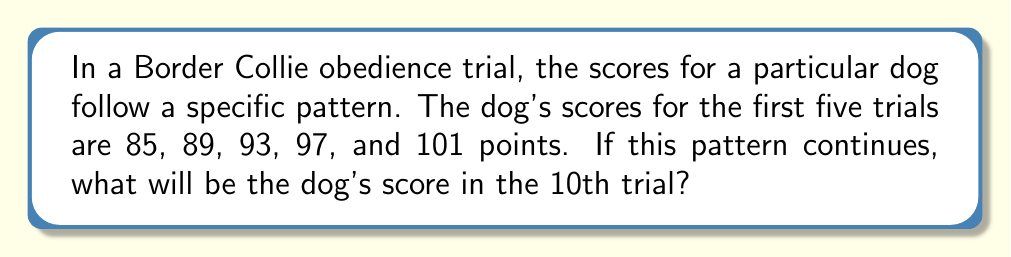Show me your answer to this math problem. To solve this problem, we need to follow these steps:

1. Identify the pattern in the given sequence:
   85, 89, 93, 97, 101

2. Calculate the difference between consecutive terms:
   89 - 85 = 4
   93 - 89 = 4
   97 - 93 = 4
   101 - 97 = 4

3. Recognize that this is an arithmetic sequence with a common difference of 4.

4. Use the arithmetic sequence formula:
   $$a_n = a_1 + (n - 1)d$$
   Where:
   $a_n$ is the nth term
   $a_1$ is the first term
   $n$ is the position of the term we're looking for
   $d$ is the common difference

5. Substitute the values:
   $a_1 = 85$ (first term)
   $n = 10$ (we want the 10th trial)
   $d = 4$ (common difference)

6. Calculate:
   $$a_{10} = 85 + (10 - 1) \times 4$$
   $$a_{10} = 85 + 9 \times 4$$
   $$a_{10} = 85 + 36$$
   $$a_{10} = 121$$

Therefore, the dog's score in the 10th trial will be 121 points.
Answer: 121 points 